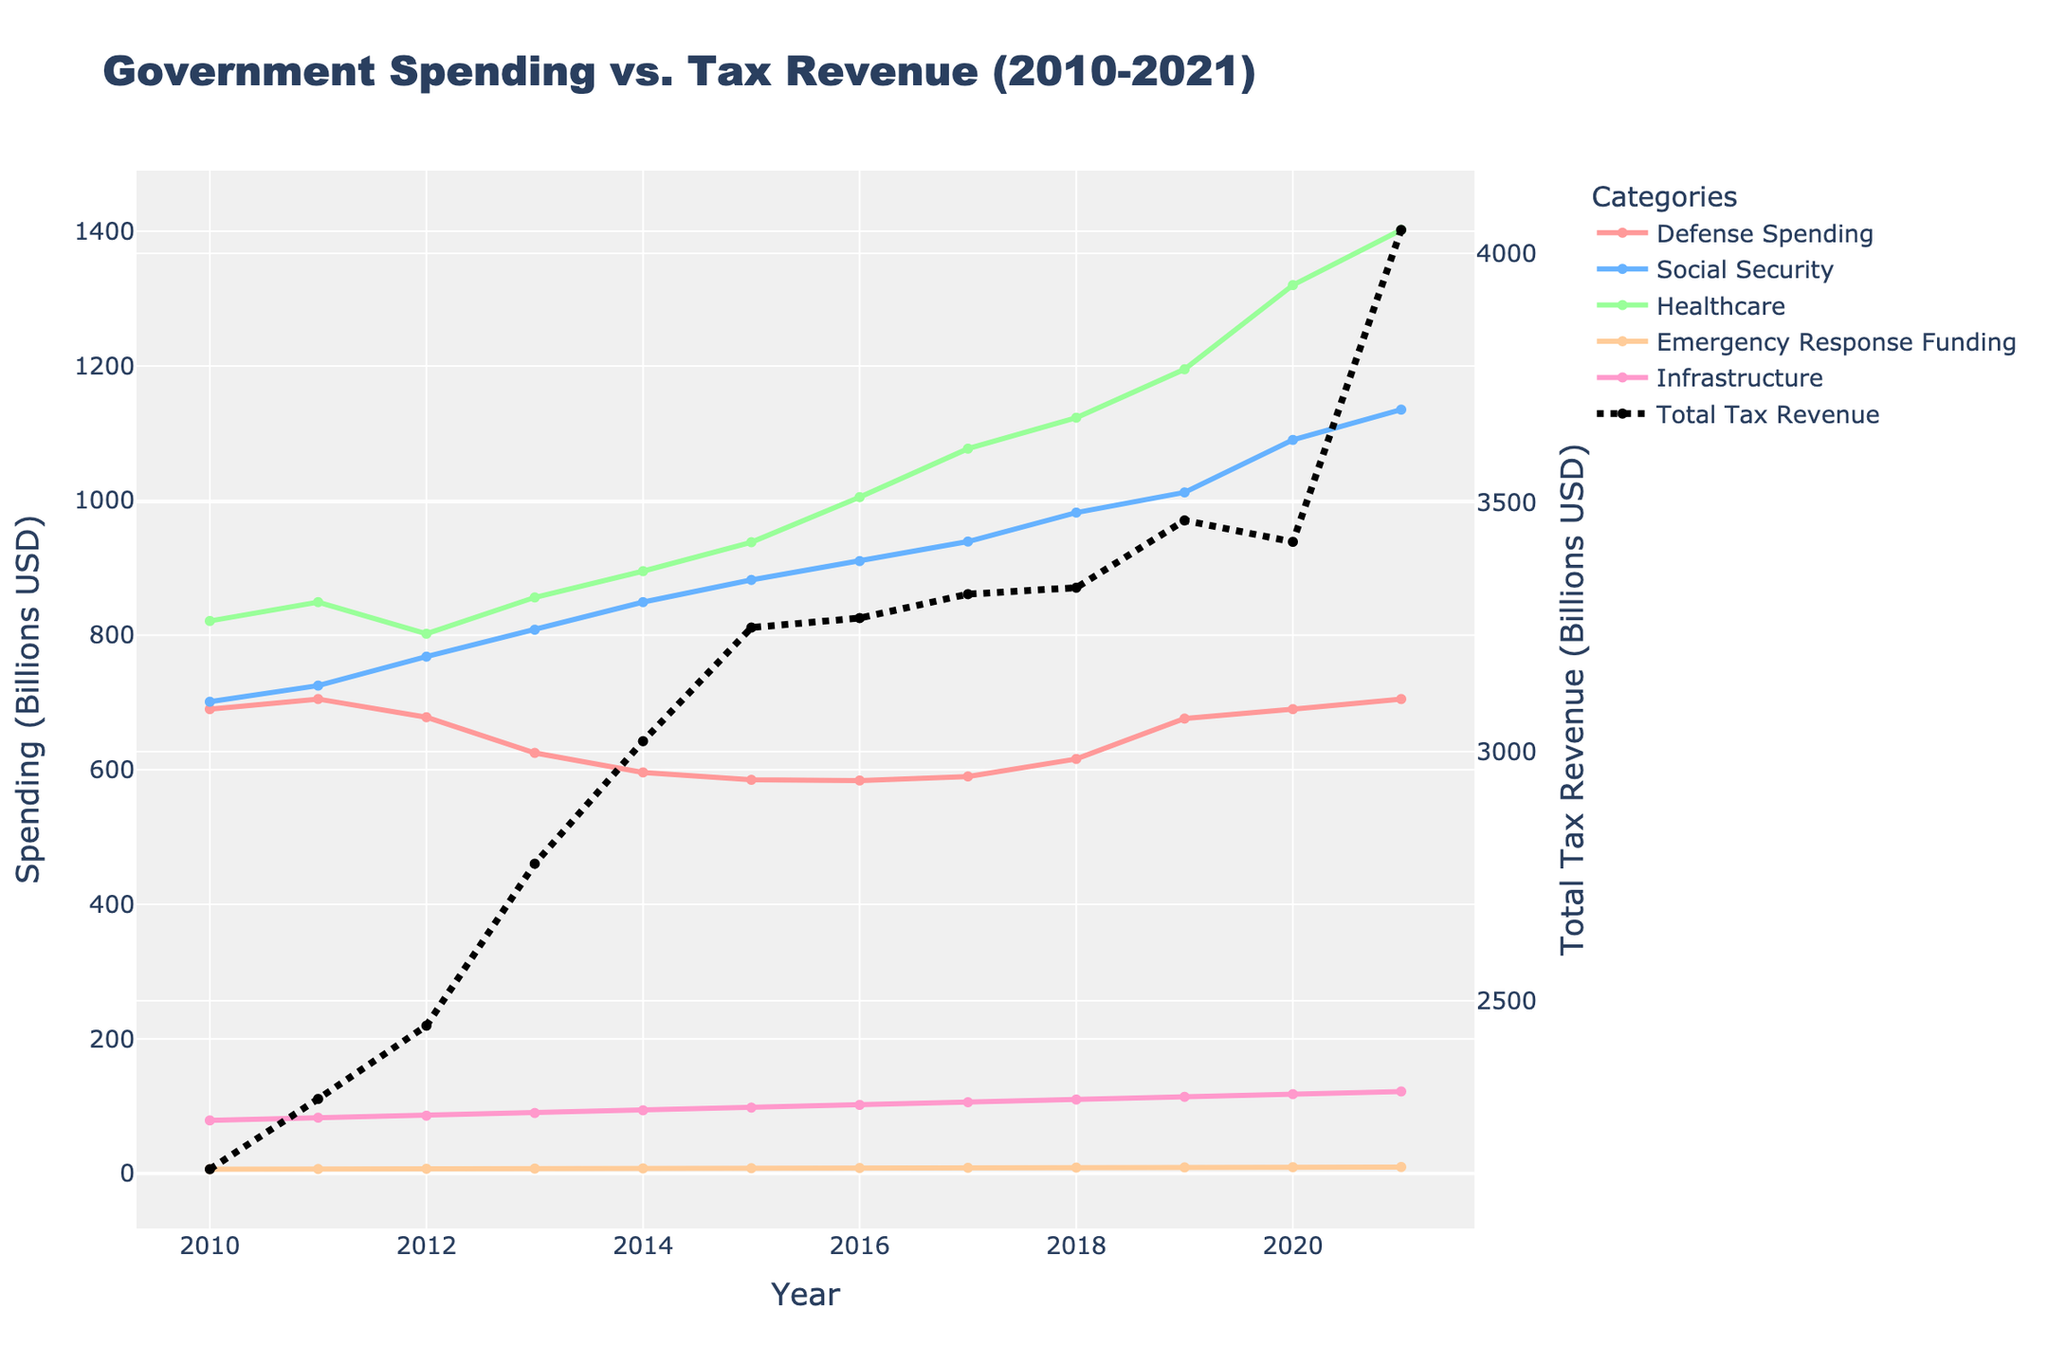What is the overall trend in Total Tax Revenue from 2010 to 2021? The Total Tax Revenue shows a general upward trend from 2162 billion USD in 2010 to 4047 billion USD in 2021, despite a slight dip in 2020.
Answer: Upward trend Which year shows the highest spending on Healthcare, and what is the amount? 2020 shows the highest spending on Healthcare at 1320 billion USD.
Answer: 2020, 1320 billion USD How does Emergency Response Funding compare to Infrastructure spending in 2021? In 2021, Emergency Response Funding is 9.8 billion USD, whereas Infrastructure spending is 122 billion USD. Emergency Response Funding is significantly lower.
Answer: Emergency Response Funding is significantly lower What is the difference in Social Security spending between 2012 and 2015? Social Security spending in 2012 was 768 billion USD and in 2015 was 882 billion USD. The difference is 882 - 768 = 114 billion USD.
Answer: 114 billion USD In which year did Defense Spending drop to its minimum value, and what was the amount? Defense Spending dropped to its minimum value in 2015 at 585 billion USD.
Answer: 2015, 585 billion USD Compare the trends of Healthcare spending and Defense Spending from 2010 to 2021. Healthcare spending shows a steady increase from 821 billion USD in 2010 to 1402 billion USD in 2021. Defense Spending shows a fluctuating trend, starting at 690 billion USD in 2010, dipping to a minimum in 2015 at 585 billion USD, and then slightly increasing to 705 billion USD by 2021.
Answer: Healthcare spending increases, Defense Spending fluctuates How does Emergency Response Funding in 2020 compare to its funding in 2010? Emergency Response Funding in 2020 is 9.5 billion USD, which is 3 billion USD higher than the 6.5 billion USD in 2010.
Answer: 3 billion USD higher If you sum up the Defense Spending and Healthcare spending in 2021, what is the total? Defense Spending in 2021 is 705 billion USD and Healthcare spending is 1402 billion USD. The total is 705 + 1402 = 2107 billion USD.
Answer: 2107 billion USD What is the average annual increase in Total Tax Revenue from 2010 to 2021? Total Tax Revenue in 2010 was 2162 billion USD and in 2021 was 4047 billion USD. The increase is 4047 - 2162 = 1885 billion USD over 11 years. The average annual increase is 1885 / 11 ≈ 171.36 billion USD.
Answer: ≈ 171.36 billion USD Considering all years, in which categories did spending generally increase over time? Spending generally increased over time in Social Security, Healthcare, Emergency Response Funding, and Infrastructure. Defense Spending fluctuated.
Answer: Social Security, Healthcare, Emergency Response Funding, Infrastructure 